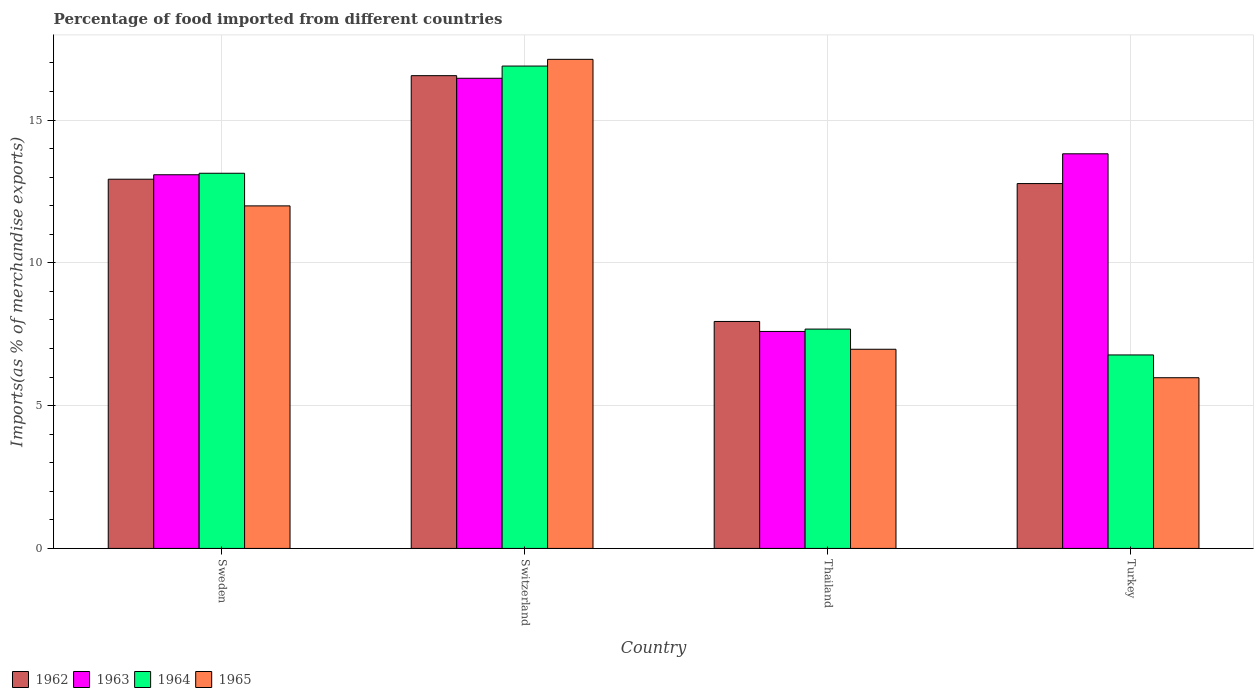How many different coloured bars are there?
Keep it short and to the point. 4. How many bars are there on the 1st tick from the right?
Your answer should be very brief. 4. What is the label of the 3rd group of bars from the left?
Keep it short and to the point. Thailand. In how many cases, is the number of bars for a given country not equal to the number of legend labels?
Your response must be concise. 0. What is the percentage of imports to different countries in 1962 in Thailand?
Offer a very short reply. 7.95. Across all countries, what is the maximum percentage of imports to different countries in 1963?
Keep it short and to the point. 16.46. Across all countries, what is the minimum percentage of imports to different countries in 1962?
Offer a very short reply. 7.95. In which country was the percentage of imports to different countries in 1963 maximum?
Your answer should be very brief. Switzerland. In which country was the percentage of imports to different countries in 1963 minimum?
Keep it short and to the point. Thailand. What is the total percentage of imports to different countries in 1965 in the graph?
Your answer should be compact. 42.07. What is the difference between the percentage of imports to different countries in 1962 in Thailand and that in Turkey?
Your response must be concise. -4.83. What is the difference between the percentage of imports to different countries in 1965 in Switzerland and the percentage of imports to different countries in 1964 in Turkey?
Your answer should be compact. 10.35. What is the average percentage of imports to different countries in 1965 per country?
Offer a very short reply. 10.52. What is the difference between the percentage of imports to different countries of/in 1964 and percentage of imports to different countries of/in 1965 in Switzerland?
Keep it short and to the point. -0.24. What is the ratio of the percentage of imports to different countries in 1962 in Sweden to that in Thailand?
Your answer should be compact. 1.63. Is the difference between the percentage of imports to different countries in 1964 in Thailand and Turkey greater than the difference between the percentage of imports to different countries in 1965 in Thailand and Turkey?
Offer a very short reply. No. What is the difference between the highest and the second highest percentage of imports to different countries in 1964?
Provide a succinct answer. 3.75. What is the difference between the highest and the lowest percentage of imports to different countries in 1962?
Offer a very short reply. 8.61. In how many countries, is the percentage of imports to different countries in 1963 greater than the average percentage of imports to different countries in 1963 taken over all countries?
Make the answer very short. 3. What does the 4th bar from the left in Switzerland represents?
Offer a very short reply. 1965. What does the 1st bar from the right in Switzerland represents?
Keep it short and to the point. 1965. Is it the case that in every country, the sum of the percentage of imports to different countries in 1963 and percentage of imports to different countries in 1965 is greater than the percentage of imports to different countries in 1964?
Your answer should be compact. Yes. What is the difference between two consecutive major ticks on the Y-axis?
Give a very brief answer. 5. Does the graph contain any zero values?
Keep it short and to the point. No. Does the graph contain grids?
Provide a succinct answer. Yes. What is the title of the graph?
Provide a short and direct response. Percentage of food imported from different countries. What is the label or title of the Y-axis?
Give a very brief answer. Imports(as % of merchandise exports). What is the Imports(as % of merchandise exports) in 1962 in Sweden?
Your response must be concise. 12.93. What is the Imports(as % of merchandise exports) in 1963 in Sweden?
Give a very brief answer. 13.08. What is the Imports(as % of merchandise exports) in 1964 in Sweden?
Your answer should be compact. 13.14. What is the Imports(as % of merchandise exports) in 1965 in Sweden?
Keep it short and to the point. 11.99. What is the Imports(as % of merchandise exports) in 1962 in Switzerland?
Make the answer very short. 16.55. What is the Imports(as % of merchandise exports) in 1963 in Switzerland?
Make the answer very short. 16.46. What is the Imports(as % of merchandise exports) in 1964 in Switzerland?
Keep it short and to the point. 16.89. What is the Imports(as % of merchandise exports) in 1965 in Switzerland?
Keep it short and to the point. 17.12. What is the Imports(as % of merchandise exports) of 1962 in Thailand?
Make the answer very short. 7.95. What is the Imports(as % of merchandise exports) in 1963 in Thailand?
Make the answer very short. 7.6. What is the Imports(as % of merchandise exports) of 1964 in Thailand?
Provide a succinct answer. 7.68. What is the Imports(as % of merchandise exports) in 1965 in Thailand?
Your answer should be compact. 6.97. What is the Imports(as % of merchandise exports) of 1962 in Turkey?
Your response must be concise. 12.77. What is the Imports(as % of merchandise exports) of 1963 in Turkey?
Keep it short and to the point. 13.82. What is the Imports(as % of merchandise exports) in 1964 in Turkey?
Your response must be concise. 6.77. What is the Imports(as % of merchandise exports) of 1965 in Turkey?
Your answer should be very brief. 5.98. Across all countries, what is the maximum Imports(as % of merchandise exports) of 1962?
Your response must be concise. 16.55. Across all countries, what is the maximum Imports(as % of merchandise exports) of 1963?
Give a very brief answer. 16.46. Across all countries, what is the maximum Imports(as % of merchandise exports) in 1964?
Make the answer very short. 16.89. Across all countries, what is the maximum Imports(as % of merchandise exports) of 1965?
Your response must be concise. 17.12. Across all countries, what is the minimum Imports(as % of merchandise exports) in 1962?
Offer a terse response. 7.95. Across all countries, what is the minimum Imports(as % of merchandise exports) in 1963?
Provide a short and direct response. 7.6. Across all countries, what is the minimum Imports(as % of merchandise exports) of 1964?
Keep it short and to the point. 6.77. Across all countries, what is the minimum Imports(as % of merchandise exports) of 1965?
Your answer should be compact. 5.98. What is the total Imports(as % of merchandise exports) of 1962 in the graph?
Provide a succinct answer. 50.2. What is the total Imports(as % of merchandise exports) in 1963 in the graph?
Ensure brevity in your answer.  50.96. What is the total Imports(as % of merchandise exports) of 1964 in the graph?
Ensure brevity in your answer.  44.48. What is the total Imports(as % of merchandise exports) in 1965 in the graph?
Your response must be concise. 42.07. What is the difference between the Imports(as % of merchandise exports) of 1962 in Sweden and that in Switzerland?
Provide a short and direct response. -3.63. What is the difference between the Imports(as % of merchandise exports) in 1963 in Sweden and that in Switzerland?
Your response must be concise. -3.38. What is the difference between the Imports(as % of merchandise exports) in 1964 in Sweden and that in Switzerland?
Make the answer very short. -3.75. What is the difference between the Imports(as % of merchandise exports) of 1965 in Sweden and that in Switzerland?
Provide a succinct answer. -5.13. What is the difference between the Imports(as % of merchandise exports) of 1962 in Sweden and that in Thailand?
Your response must be concise. 4.98. What is the difference between the Imports(as % of merchandise exports) in 1963 in Sweden and that in Thailand?
Your answer should be compact. 5.49. What is the difference between the Imports(as % of merchandise exports) of 1964 in Sweden and that in Thailand?
Your answer should be compact. 5.46. What is the difference between the Imports(as % of merchandise exports) of 1965 in Sweden and that in Thailand?
Provide a succinct answer. 5.02. What is the difference between the Imports(as % of merchandise exports) in 1962 in Sweden and that in Turkey?
Give a very brief answer. 0.15. What is the difference between the Imports(as % of merchandise exports) in 1963 in Sweden and that in Turkey?
Your answer should be very brief. -0.73. What is the difference between the Imports(as % of merchandise exports) in 1964 in Sweden and that in Turkey?
Provide a short and direct response. 6.36. What is the difference between the Imports(as % of merchandise exports) of 1965 in Sweden and that in Turkey?
Your answer should be very brief. 6.02. What is the difference between the Imports(as % of merchandise exports) of 1962 in Switzerland and that in Thailand?
Ensure brevity in your answer.  8.61. What is the difference between the Imports(as % of merchandise exports) in 1963 in Switzerland and that in Thailand?
Ensure brevity in your answer.  8.86. What is the difference between the Imports(as % of merchandise exports) of 1964 in Switzerland and that in Thailand?
Your response must be concise. 9.21. What is the difference between the Imports(as % of merchandise exports) of 1965 in Switzerland and that in Thailand?
Provide a short and direct response. 10.15. What is the difference between the Imports(as % of merchandise exports) in 1962 in Switzerland and that in Turkey?
Offer a very short reply. 3.78. What is the difference between the Imports(as % of merchandise exports) of 1963 in Switzerland and that in Turkey?
Ensure brevity in your answer.  2.64. What is the difference between the Imports(as % of merchandise exports) in 1964 in Switzerland and that in Turkey?
Provide a short and direct response. 10.11. What is the difference between the Imports(as % of merchandise exports) of 1965 in Switzerland and that in Turkey?
Make the answer very short. 11.15. What is the difference between the Imports(as % of merchandise exports) in 1962 in Thailand and that in Turkey?
Offer a terse response. -4.83. What is the difference between the Imports(as % of merchandise exports) of 1963 in Thailand and that in Turkey?
Keep it short and to the point. -6.22. What is the difference between the Imports(as % of merchandise exports) in 1964 in Thailand and that in Turkey?
Ensure brevity in your answer.  0.91. What is the difference between the Imports(as % of merchandise exports) in 1962 in Sweden and the Imports(as % of merchandise exports) in 1963 in Switzerland?
Keep it short and to the point. -3.53. What is the difference between the Imports(as % of merchandise exports) in 1962 in Sweden and the Imports(as % of merchandise exports) in 1964 in Switzerland?
Give a very brief answer. -3.96. What is the difference between the Imports(as % of merchandise exports) of 1962 in Sweden and the Imports(as % of merchandise exports) of 1965 in Switzerland?
Offer a very short reply. -4.2. What is the difference between the Imports(as % of merchandise exports) in 1963 in Sweden and the Imports(as % of merchandise exports) in 1964 in Switzerland?
Make the answer very short. -3.81. What is the difference between the Imports(as % of merchandise exports) in 1963 in Sweden and the Imports(as % of merchandise exports) in 1965 in Switzerland?
Your answer should be compact. -4.04. What is the difference between the Imports(as % of merchandise exports) in 1964 in Sweden and the Imports(as % of merchandise exports) in 1965 in Switzerland?
Your answer should be compact. -3.99. What is the difference between the Imports(as % of merchandise exports) of 1962 in Sweden and the Imports(as % of merchandise exports) of 1963 in Thailand?
Offer a very short reply. 5.33. What is the difference between the Imports(as % of merchandise exports) of 1962 in Sweden and the Imports(as % of merchandise exports) of 1964 in Thailand?
Your answer should be compact. 5.25. What is the difference between the Imports(as % of merchandise exports) of 1962 in Sweden and the Imports(as % of merchandise exports) of 1965 in Thailand?
Make the answer very short. 5.95. What is the difference between the Imports(as % of merchandise exports) of 1963 in Sweden and the Imports(as % of merchandise exports) of 1964 in Thailand?
Your response must be concise. 5.4. What is the difference between the Imports(as % of merchandise exports) of 1963 in Sweden and the Imports(as % of merchandise exports) of 1965 in Thailand?
Offer a very short reply. 6.11. What is the difference between the Imports(as % of merchandise exports) in 1964 in Sweden and the Imports(as % of merchandise exports) in 1965 in Thailand?
Your response must be concise. 6.16. What is the difference between the Imports(as % of merchandise exports) in 1962 in Sweden and the Imports(as % of merchandise exports) in 1963 in Turkey?
Your answer should be compact. -0.89. What is the difference between the Imports(as % of merchandise exports) of 1962 in Sweden and the Imports(as % of merchandise exports) of 1964 in Turkey?
Offer a very short reply. 6.15. What is the difference between the Imports(as % of merchandise exports) in 1962 in Sweden and the Imports(as % of merchandise exports) in 1965 in Turkey?
Make the answer very short. 6.95. What is the difference between the Imports(as % of merchandise exports) in 1963 in Sweden and the Imports(as % of merchandise exports) in 1964 in Turkey?
Make the answer very short. 6.31. What is the difference between the Imports(as % of merchandise exports) of 1963 in Sweden and the Imports(as % of merchandise exports) of 1965 in Turkey?
Give a very brief answer. 7.11. What is the difference between the Imports(as % of merchandise exports) in 1964 in Sweden and the Imports(as % of merchandise exports) in 1965 in Turkey?
Your response must be concise. 7.16. What is the difference between the Imports(as % of merchandise exports) of 1962 in Switzerland and the Imports(as % of merchandise exports) of 1963 in Thailand?
Your answer should be very brief. 8.96. What is the difference between the Imports(as % of merchandise exports) in 1962 in Switzerland and the Imports(as % of merchandise exports) in 1964 in Thailand?
Provide a succinct answer. 8.87. What is the difference between the Imports(as % of merchandise exports) of 1962 in Switzerland and the Imports(as % of merchandise exports) of 1965 in Thailand?
Your answer should be compact. 9.58. What is the difference between the Imports(as % of merchandise exports) of 1963 in Switzerland and the Imports(as % of merchandise exports) of 1964 in Thailand?
Ensure brevity in your answer.  8.78. What is the difference between the Imports(as % of merchandise exports) in 1963 in Switzerland and the Imports(as % of merchandise exports) in 1965 in Thailand?
Offer a terse response. 9.49. What is the difference between the Imports(as % of merchandise exports) of 1964 in Switzerland and the Imports(as % of merchandise exports) of 1965 in Thailand?
Offer a very short reply. 9.92. What is the difference between the Imports(as % of merchandise exports) in 1962 in Switzerland and the Imports(as % of merchandise exports) in 1963 in Turkey?
Make the answer very short. 2.74. What is the difference between the Imports(as % of merchandise exports) in 1962 in Switzerland and the Imports(as % of merchandise exports) in 1964 in Turkey?
Your answer should be compact. 9.78. What is the difference between the Imports(as % of merchandise exports) in 1962 in Switzerland and the Imports(as % of merchandise exports) in 1965 in Turkey?
Your answer should be very brief. 10.58. What is the difference between the Imports(as % of merchandise exports) of 1963 in Switzerland and the Imports(as % of merchandise exports) of 1964 in Turkey?
Provide a succinct answer. 9.69. What is the difference between the Imports(as % of merchandise exports) of 1963 in Switzerland and the Imports(as % of merchandise exports) of 1965 in Turkey?
Provide a succinct answer. 10.48. What is the difference between the Imports(as % of merchandise exports) in 1964 in Switzerland and the Imports(as % of merchandise exports) in 1965 in Turkey?
Provide a succinct answer. 10.91. What is the difference between the Imports(as % of merchandise exports) of 1962 in Thailand and the Imports(as % of merchandise exports) of 1963 in Turkey?
Offer a very short reply. -5.87. What is the difference between the Imports(as % of merchandise exports) of 1962 in Thailand and the Imports(as % of merchandise exports) of 1964 in Turkey?
Make the answer very short. 1.17. What is the difference between the Imports(as % of merchandise exports) of 1962 in Thailand and the Imports(as % of merchandise exports) of 1965 in Turkey?
Provide a short and direct response. 1.97. What is the difference between the Imports(as % of merchandise exports) of 1963 in Thailand and the Imports(as % of merchandise exports) of 1964 in Turkey?
Your answer should be compact. 0.82. What is the difference between the Imports(as % of merchandise exports) in 1963 in Thailand and the Imports(as % of merchandise exports) in 1965 in Turkey?
Your response must be concise. 1.62. What is the difference between the Imports(as % of merchandise exports) of 1964 in Thailand and the Imports(as % of merchandise exports) of 1965 in Turkey?
Your answer should be very brief. 1.7. What is the average Imports(as % of merchandise exports) in 1962 per country?
Offer a terse response. 12.55. What is the average Imports(as % of merchandise exports) of 1963 per country?
Your response must be concise. 12.74. What is the average Imports(as % of merchandise exports) in 1964 per country?
Offer a terse response. 11.12. What is the average Imports(as % of merchandise exports) in 1965 per country?
Offer a very short reply. 10.52. What is the difference between the Imports(as % of merchandise exports) of 1962 and Imports(as % of merchandise exports) of 1963 in Sweden?
Your response must be concise. -0.16. What is the difference between the Imports(as % of merchandise exports) in 1962 and Imports(as % of merchandise exports) in 1964 in Sweden?
Offer a terse response. -0.21. What is the difference between the Imports(as % of merchandise exports) in 1962 and Imports(as % of merchandise exports) in 1965 in Sweden?
Provide a short and direct response. 0.93. What is the difference between the Imports(as % of merchandise exports) of 1963 and Imports(as % of merchandise exports) of 1964 in Sweden?
Keep it short and to the point. -0.05. What is the difference between the Imports(as % of merchandise exports) in 1963 and Imports(as % of merchandise exports) in 1965 in Sweden?
Your response must be concise. 1.09. What is the difference between the Imports(as % of merchandise exports) of 1964 and Imports(as % of merchandise exports) of 1965 in Sweden?
Your answer should be very brief. 1.14. What is the difference between the Imports(as % of merchandise exports) in 1962 and Imports(as % of merchandise exports) in 1963 in Switzerland?
Your answer should be compact. 0.09. What is the difference between the Imports(as % of merchandise exports) in 1962 and Imports(as % of merchandise exports) in 1964 in Switzerland?
Your answer should be compact. -0.34. What is the difference between the Imports(as % of merchandise exports) in 1962 and Imports(as % of merchandise exports) in 1965 in Switzerland?
Your answer should be compact. -0.57. What is the difference between the Imports(as % of merchandise exports) in 1963 and Imports(as % of merchandise exports) in 1964 in Switzerland?
Your response must be concise. -0.43. What is the difference between the Imports(as % of merchandise exports) of 1963 and Imports(as % of merchandise exports) of 1965 in Switzerland?
Provide a succinct answer. -0.66. What is the difference between the Imports(as % of merchandise exports) of 1964 and Imports(as % of merchandise exports) of 1965 in Switzerland?
Your answer should be very brief. -0.24. What is the difference between the Imports(as % of merchandise exports) in 1962 and Imports(as % of merchandise exports) in 1963 in Thailand?
Keep it short and to the point. 0.35. What is the difference between the Imports(as % of merchandise exports) of 1962 and Imports(as % of merchandise exports) of 1964 in Thailand?
Your response must be concise. 0.27. What is the difference between the Imports(as % of merchandise exports) of 1962 and Imports(as % of merchandise exports) of 1965 in Thailand?
Your answer should be very brief. 0.97. What is the difference between the Imports(as % of merchandise exports) in 1963 and Imports(as % of merchandise exports) in 1964 in Thailand?
Give a very brief answer. -0.08. What is the difference between the Imports(as % of merchandise exports) of 1963 and Imports(as % of merchandise exports) of 1965 in Thailand?
Provide a succinct answer. 0.62. What is the difference between the Imports(as % of merchandise exports) of 1964 and Imports(as % of merchandise exports) of 1965 in Thailand?
Your response must be concise. 0.71. What is the difference between the Imports(as % of merchandise exports) in 1962 and Imports(as % of merchandise exports) in 1963 in Turkey?
Give a very brief answer. -1.04. What is the difference between the Imports(as % of merchandise exports) of 1962 and Imports(as % of merchandise exports) of 1964 in Turkey?
Your response must be concise. 6. What is the difference between the Imports(as % of merchandise exports) of 1962 and Imports(as % of merchandise exports) of 1965 in Turkey?
Offer a very short reply. 6.8. What is the difference between the Imports(as % of merchandise exports) of 1963 and Imports(as % of merchandise exports) of 1964 in Turkey?
Offer a very short reply. 7.04. What is the difference between the Imports(as % of merchandise exports) of 1963 and Imports(as % of merchandise exports) of 1965 in Turkey?
Your answer should be compact. 7.84. What is the difference between the Imports(as % of merchandise exports) of 1964 and Imports(as % of merchandise exports) of 1965 in Turkey?
Give a very brief answer. 0.8. What is the ratio of the Imports(as % of merchandise exports) of 1962 in Sweden to that in Switzerland?
Make the answer very short. 0.78. What is the ratio of the Imports(as % of merchandise exports) of 1963 in Sweden to that in Switzerland?
Your answer should be compact. 0.79. What is the ratio of the Imports(as % of merchandise exports) in 1964 in Sweden to that in Switzerland?
Your response must be concise. 0.78. What is the ratio of the Imports(as % of merchandise exports) of 1965 in Sweden to that in Switzerland?
Keep it short and to the point. 0.7. What is the ratio of the Imports(as % of merchandise exports) in 1962 in Sweden to that in Thailand?
Your answer should be compact. 1.63. What is the ratio of the Imports(as % of merchandise exports) in 1963 in Sweden to that in Thailand?
Offer a terse response. 1.72. What is the ratio of the Imports(as % of merchandise exports) in 1964 in Sweden to that in Thailand?
Keep it short and to the point. 1.71. What is the ratio of the Imports(as % of merchandise exports) in 1965 in Sweden to that in Thailand?
Offer a terse response. 1.72. What is the ratio of the Imports(as % of merchandise exports) of 1962 in Sweden to that in Turkey?
Offer a very short reply. 1.01. What is the ratio of the Imports(as % of merchandise exports) in 1963 in Sweden to that in Turkey?
Offer a very short reply. 0.95. What is the ratio of the Imports(as % of merchandise exports) in 1964 in Sweden to that in Turkey?
Give a very brief answer. 1.94. What is the ratio of the Imports(as % of merchandise exports) of 1965 in Sweden to that in Turkey?
Provide a short and direct response. 2.01. What is the ratio of the Imports(as % of merchandise exports) of 1962 in Switzerland to that in Thailand?
Provide a short and direct response. 2.08. What is the ratio of the Imports(as % of merchandise exports) of 1963 in Switzerland to that in Thailand?
Offer a very short reply. 2.17. What is the ratio of the Imports(as % of merchandise exports) in 1964 in Switzerland to that in Thailand?
Give a very brief answer. 2.2. What is the ratio of the Imports(as % of merchandise exports) in 1965 in Switzerland to that in Thailand?
Offer a very short reply. 2.46. What is the ratio of the Imports(as % of merchandise exports) in 1962 in Switzerland to that in Turkey?
Your answer should be very brief. 1.3. What is the ratio of the Imports(as % of merchandise exports) in 1963 in Switzerland to that in Turkey?
Provide a short and direct response. 1.19. What is the ratio of the Imports(as % of merchandise exports) in 1964 in Switzerland to that in Turkey?
Make the answer very short. 2.49. What is the ratio of the Imports(as % of merchandise exports) of 1965 in Switzerland to that in Turkey?
Give a very brief answer. 2.87. What is the ratio of the Imports(as % of merchandise exports) of 1962 in Thailand to that in Turkey?
Ensure brevity in your answer.  0.62. What is the ratio of the Imports(as % of merchandise exports) in 1963 in Thailand to that in Turkey?
Offer a terse response. 0.55. What is the ratio of the Imports(as % of merchandise exports) of 1964 in Thailand to that in Turkey?
Give a very brief answer. 1.13. What is the ratio of the Imports(as % of merchandise exports) of 1965 in Thailand to that in Turkey?
Offer a very short reply. 1.17. What is the difference between the highest and the second highest Imports(as % of merchandise exports) in 1962?
Keep it short and to the point. 3.63. What is the difference between the highest and the second highest Imports(as % of merchandise exports) in 1963?
Provide a succinct answer. 2.64. What is the difference between the highest and the second highest Imports(as % of merchandise exports) of 1964?
Keep it short and to the point. 3.75. What is the difference between the highest and the second highest Imports(as % of merchandise exports) of 1965?
Ensure brevity in your answer.  5.13. What is the difference between the highest and the lowest Imports(as % of merchandise exports) in 1962?
Keep it short and to the point. 8.61. What is the difference between the highest and the lowest Imports(as % of merchandise exports) of 1963?
Offer a terse response. 8.86. What is the difference between the highest and the lowest Imports(as % of merchandise exports) in 1964?
Provide a short and direct response. 10.11. What is the difference between the highest and the lowest Imports(as % of merchandise exports) in 1965?
Your answer should be compact. 11.15. 